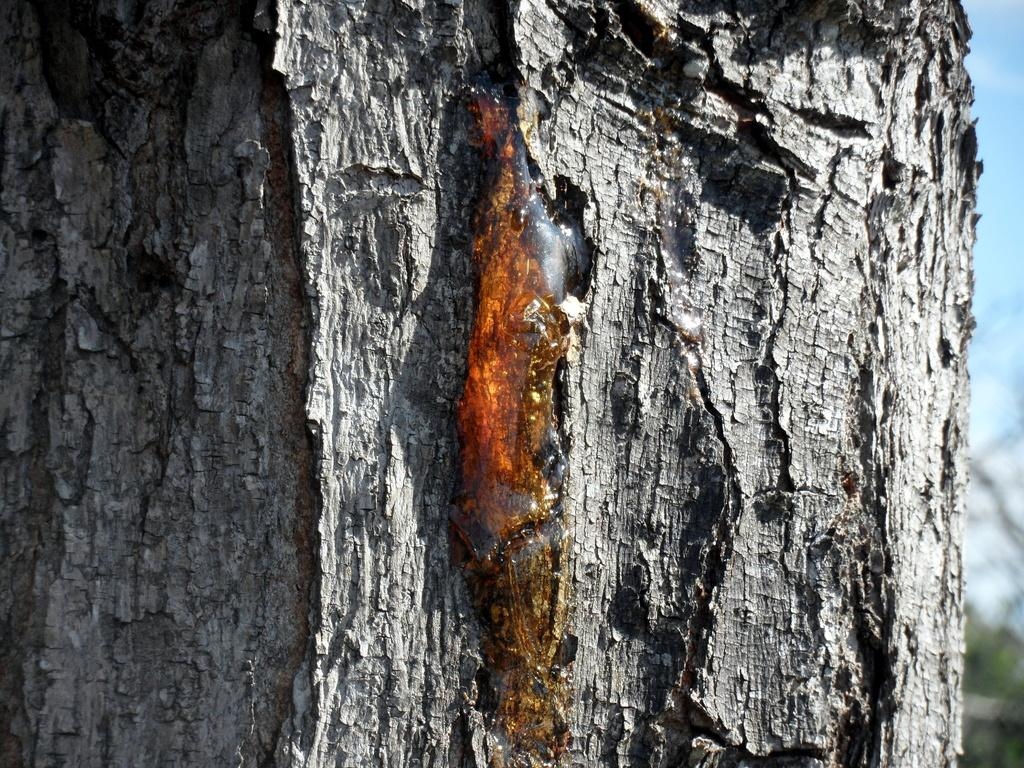What is the main subject of the picture? The main subject of the picture is a tree trunk. Can you describe any specific features of the tree trunk? Tree sap is visible on the trunk. How many windows can be seen on the yak in the picture? There is no yak present in the image, and therefore no windows can be seen on it. 